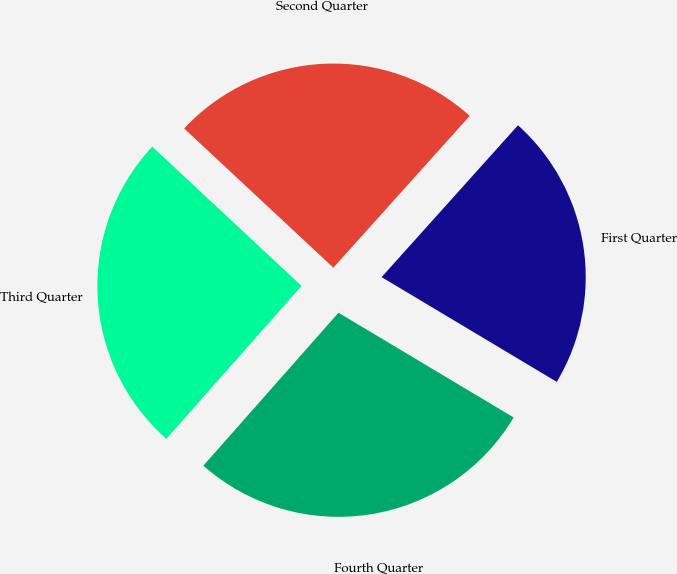Convert chart to OTSL. <chart><loc_0><loc_0><loc_500><loc_500><pie_chart><fcel>Fourth Quarter<fcel>Third Quarter<fcel>Second Quarter<fcel>First Quarter<nl><fcel>27.94%<fcel>25.43%<fcel>24.7%<fcel>21.93%<nl></chart> 